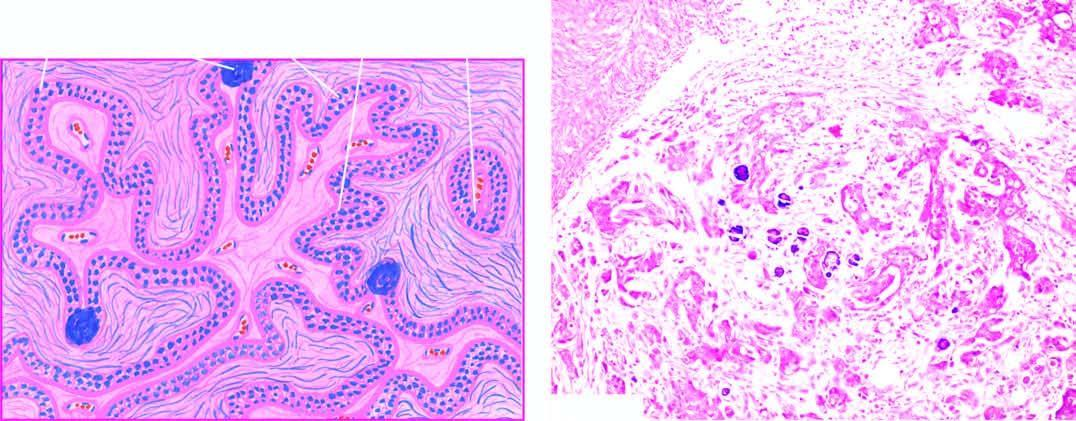what does the stroma show by clusters of anaplastic tumour cells?
Answer the question using a single word or phrase. Invasion 